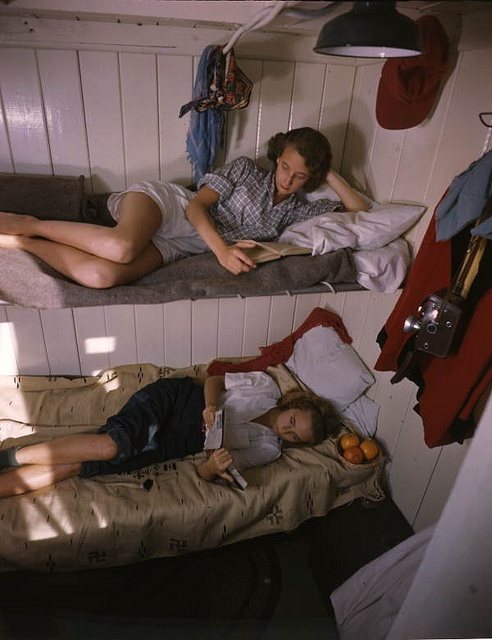Describe the objects in this image and their specific colors. I can see bed in black, gray, and maroon tones, bed in black and gray tones, people in black, gray, brown, and maroon tones, people in black, gray, and maroon tones, and book in black, gray, and maroon tones in this image. 